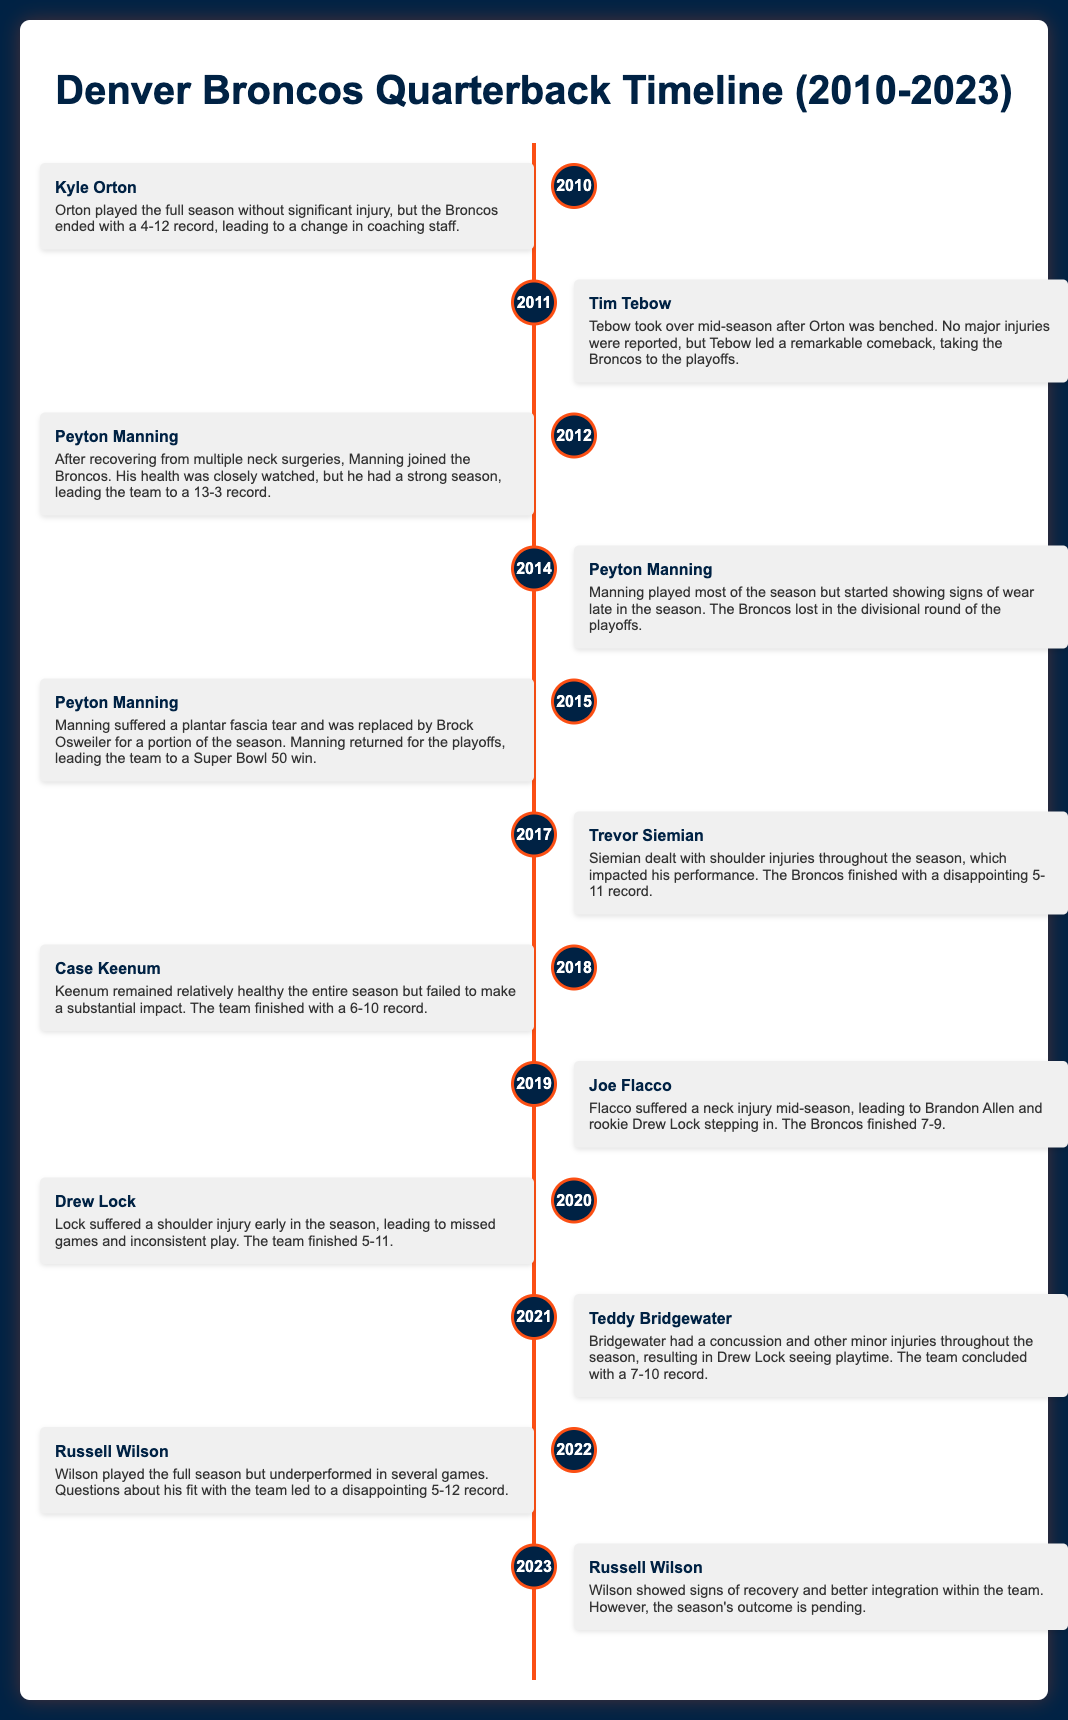What year did Kyle Orton play without significant injury? Kyle Orton played the full season in 2010 without significant injury.
Answer: 2010 Which quarterback suffered a neck injury in 2019? Joe Flacco suffered a neck injury mid-season in 2019.
Answer: Joe Flacco How many wins did the Broncos achieve in the 2015 season? The Broncos won Super Bowl 50 in the 2015 season, indicating they had a successful year despite Manning's injury.
Answer: Super Bowl 50 win Which quarterback took over after Kyle Orton was benched? Tim Tebow took over after Orton was benched mid-season in 2011.
Answer: Tim Tebow What significant injury did Drew Lock face in 2020? Drew Lock suffered a shoulder injury early in the 2020 season.
Answer: Shoulder injury In which season did Teddy Bridgewater experience a concussion? Teddy Bridgewater had a concussion and other minor injuries throughout the 2021 season.
Answer: 2021 How many total seasons did Peyton Manning play with the Broncos as mentioned? Peyton Manning played with the Broncos from 2012 to 2015, which accounts for four seasons.
Answer: Four seasons What was the Broncos' record in 2022 under Russell Wilson? The Broncos finished with a disappointing 5-12 record in 2022 under Russell Wilson.
Answer: 5-12 What impact did Trevor Siemian's shoulder injuries have on his performance? Siemian's shoulder injuries impacted his performance, contributing to a disappointing 5-11 record in 2017.
Answer: 5-11 record 